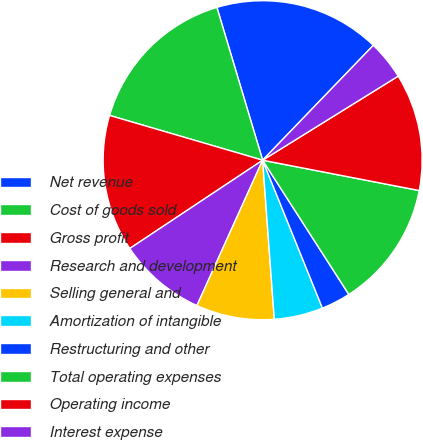Convert chart to OTSL. <chart><loc_0><loc_0><loc_500><loc_500><pie_chart><fcel>Net revenue<fcel>Cost of goods sold<fcel>Gross profit<fcel>Research and development<fcel>Selling general and<fcel>Amortization of intangible<fcel>Restructuring and other<fcel>Total operating expenses<fcel>Operating income<fcel>Interest expense<nl><fcel>16.83%<fcel>15.84%<fcel>13.86%<fcel>8.91%<fcel>7.92%<fcel>4.95%<fcel>2.97%<fcel>12.87%<fcel>11.88%<fcel>3.96%<nl></chart> 